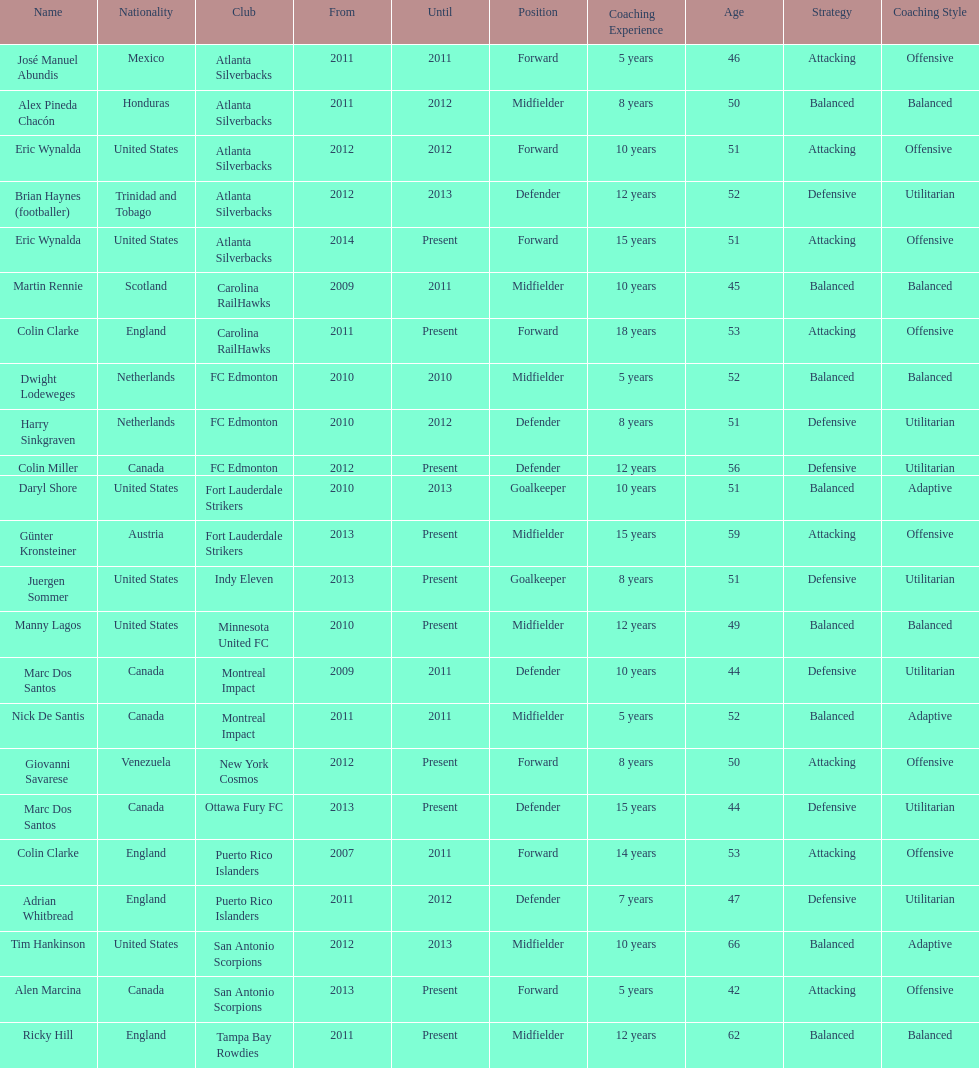How many total coaches on the list are from canada? 5. 